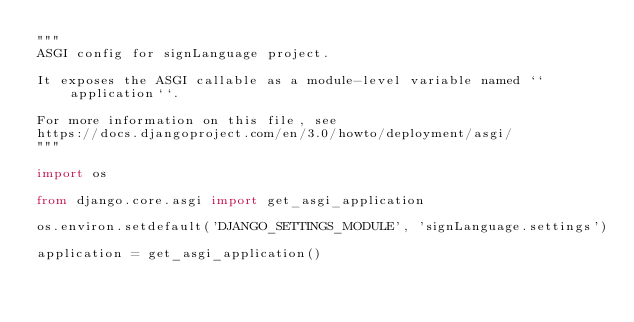<code> <loc_0><loc_0><loc_500><loc_500><_Python_>"""
ASGI config for signLanguage project.

It exposes the ASGI callable as a module-level variable named ``application``.

For more information on this file, see
https://docs.djangoproject.com/en/3.0/howto/deployment/asgi/
"""

import os

from django.core.asgi import get_asgi_application

os.environ.setdefault('DJANGO_SETTINGS_MODULE', 'signLanguage.settings')

application = get_asgi_application()
</code> 